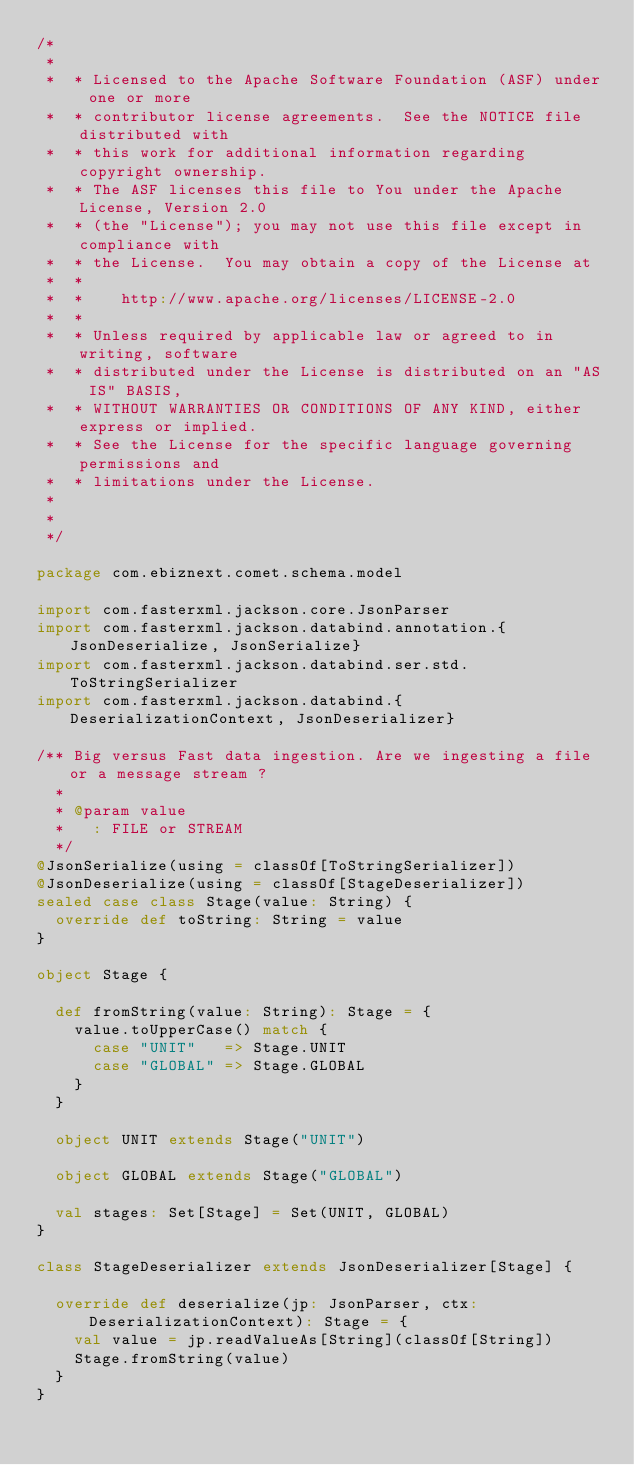Convert code to text. <code><loc_0><loc_0><loc_500><loc_500><_Scala_>/*
 *
 *  * Licensed to the Apache Software Foundation (ASF) under one or more
 *  * contributor license agreements.  See the NOTICE file distributed with
 *  * this work for additional information regarding copyright ownership.
 *  * The ASF licenses this file to You under the Apache License, Version 2.0
 *  * (the "License"); you may not use this file except in compliance with
 *  * the License.  You may obtain a copy of the License at
 *  *
 *  *    http://www.apache.org/licenses/LICENSE-2.0
 *  *
 *  * Unless required by applicable law or agreed to in writing, software
 *  * distributed under the License is distributed on an "AS IS" BASIS,
 *  * WITHOUT WARRANTIES OR CONDITIONS OF ANY KIND, either express or implied.
 *  * See the License for the specific language governing permissions and
 *  * limitations under the License.
 *
 *
 */

package com.ebiznext.comet.schema.model

import com.fasterxml.jackson.core.JsonParser
import com.fasterxml.jackson.databind.annotation.{JsonDeserialize, JsonSerialize}
import com.fasterxml.jackson.databind.ser.std.ToStringSerializer
import com.fasterxml.jackson.databind.{DeserializationContext, JsonDeserializer}

/** Big versus Fast data ingestion. Are we ingesting a file or a message stream ?
  *
  * @param value
  *   : FILE or STREAM
  */
@JsonSerialize(using = classOf[ToStringSerializer])
@JsonDeserialize(using = classOf[StageDeserializer])
sealed case class Stage(value: String) {
  override def toString: String = value
}

object Stage {

  def fromString(value: String): Stage = {
    value.toUpperCase() match {
      case "UNIT"   => Stage.UNIT
      case "GLOBAL" => Stage.GLOBAL
    }
  }

  object UNIT extends Stage("UNIT")

  object GLOBAL extends Stage("GLOBAL")

  val stages: Set[Stage] = Set(UNIT, GLOBAL)
}

class StageDeserializer extends JsonDeserializer[Stage] {

  override def deserialize(jp: JsonParser, ctx: DeserializationContext): Stage = {
    val value = jp.readValueAs[String](classOf[String])
    Stage.fromString(value)
  }
}
</code> 